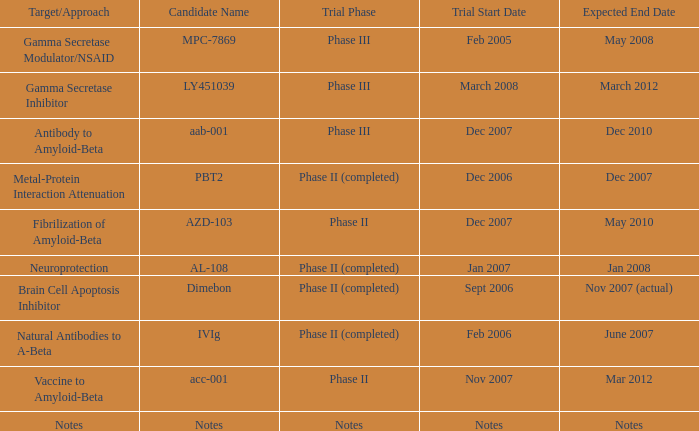What is Trial Start Date, when Candidate Name is PBT2? Dec 2006. Would you mind parsing the complete table? {'header': ['Target/Approach', 'Candidate Name', 'Trial Phase', 'Trial Start Date', 'Expected End Date'], 'rows': [['Gamma Secretase Modulator/NSAID', 'MPC-7869', 'Phase III', 'Feb 2005', 'May 2008'], ['Gamma Secretase Inhibitor', 'LY451039', 'Phase III', 'March 2008', 'March 2012'], ['Antibody to Amyloid-Beta', 'aab-001', 'Phase III', 'Dec 2007', 'Dec 2010'], ['Metal-Protein Interaction Attenuation', 'PBT2', 'Phase II (completed)', 'Dec 2006', 'Dec 2007'], ['Fibrilization of Amyloid-Beta', 'AZD-103', 'Phase II', 'Dec 2007', 'May 2010'], ['Neuroprotection', 'AL-108', 'Phase II (completed)', 'Jan 2007', 'Jan 2008'], ['Brain Cell Apoptosis Inhibitor', 'Dimebon', 'Phase II (completed)', 'Sept 2006', 'Nov 2007 (actual)'], ['Natural Antibodies to A-Beta', 'IVIg', 'Phase II (completed)', 'Feb 2006', 'June 2007'], ['Vaccine to Amyloid-Beta', 'acc-001', 'Phase II', 'Nov 2007', 'Mar 2012'], ['Notes', 'Notes', 'Notes', 'Notes', 'Notes']]} 